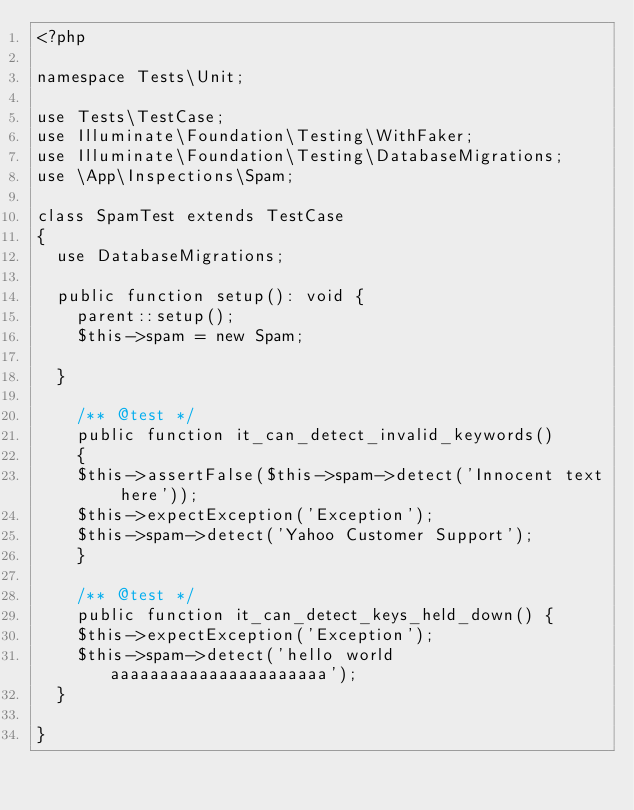<code> <loc_0><loc_0><loc_500><loc_500><_PHP_><?php

namespace Tests\Unit;

use Tests\TestCase;
use Illuminate\Foundation\Testing\WithFaker;
use Illuminate\Foundation\Testing\DatabaseMigrations;
use \App\Inspections\Spam;

class SpamTest extends TestCase
{
	use DatabaseMigrations;

	public function setup(): void {
		parent::setup();
		$this->spam = new Spam;

	}

    /** @test */
    public function it_can_detect_invalid_keywords()
    {
		$this->assertFalse($this->spam->detect('Innocent text here'));
		$this->expectException('Exception');
		$this->spam->detect('Yahoo Customer Support');
    }

    /** @test */
    public function it_can_detect_keys_held_down() {
		$this->expectException('Exception');
		$this->spam->detect('hello world aaaaaaaaaaaaaaaaaaaaaa');
	}

}
</code> 